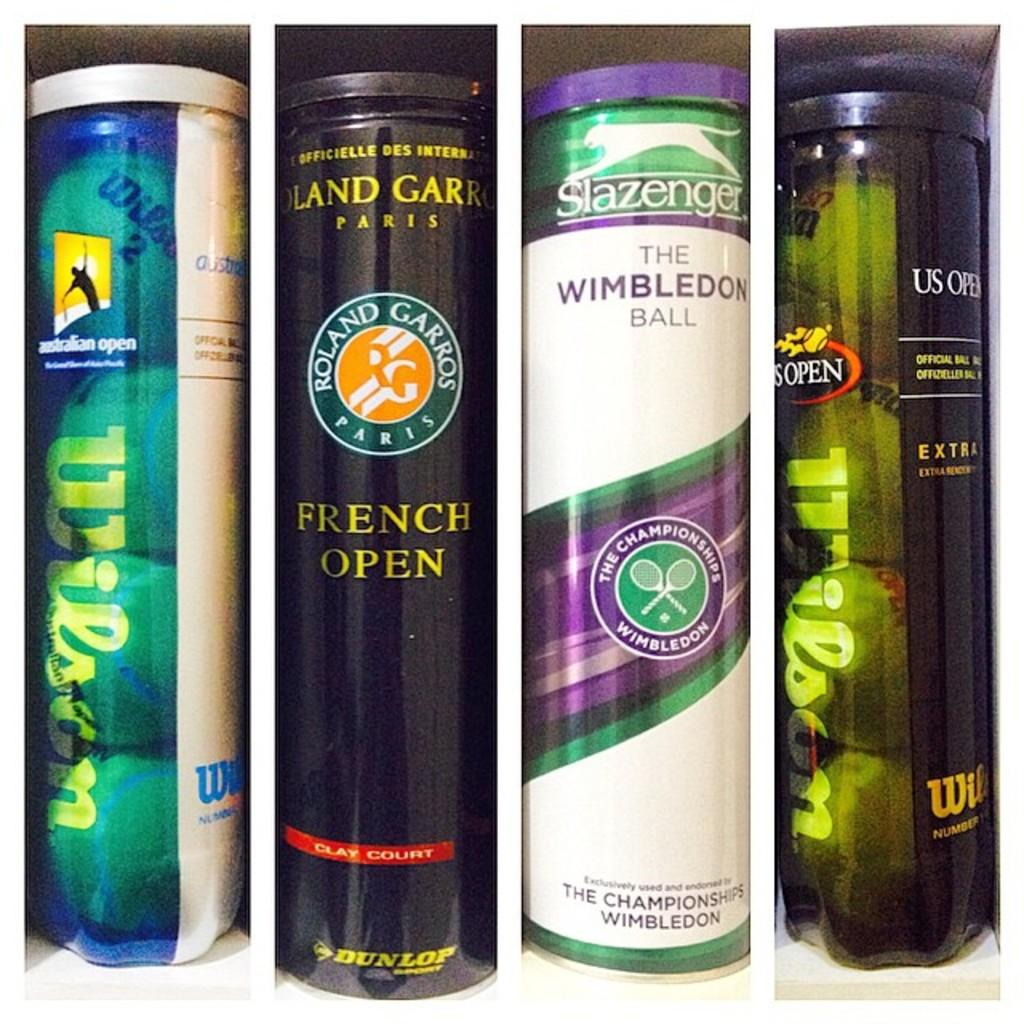<image>
Offer a succinct explanation of the picture presented. Several cans of tennis balls are lined up, including one with a label that says Roland Garros. 